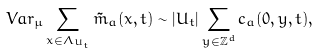Convert formula to latex. <formula><loc_0><loc_0><loc_500><loc_500>V a r _ { \mu } \sum _ { x \in \Lambda _ { U _ { t } } } \tilde { m } _ { a } ( x , t ) \sim | U _ { t } | \sum _ { y \in { \mathbb { Z } } ^ { d } } c _ { a } ( 0 , y , t ) ,</formula> 